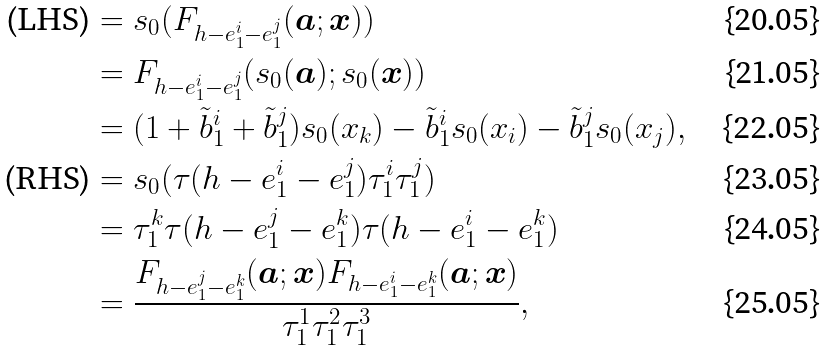<formula> <loc_0><loc_0><loc_500><loc_500>\text {(LHS)} & = s _ { 0 } ( F _ { h - e _ { 1 } ^ { i } - e _ { 1 } ^ { j } } ( { \boldsymbol a } ; { \boldsymbol x } ) ) \\ & = F _ { h - e _ { 1 } ^ { i } - e _ { 1 } ^ { j } } ( s _ { 0 } ( { \boldsymbol a } ) ; s _ { 0 } ( { \boldsymbol x } ) ) \\ & = ( 1 + \tilde { b } _ { 1 } ^ { i } + \tilde { b } _ { 1 } ^ { j } ) s _ { 0 } ( x _ { k } ) - \tilde { b } _ { 1 } ^ { i } s _ { 0 } ( x _ { i } ) - \tilde { b } _ { 1 } ^ { j } s _ { 0 } ( x _ { j } ) , \\ \text {(RHS)} & = s _ { 0 } ( \tau ( h - e _ { 1 } ^ { i } - e _ { 1 } ^ { j } ) \tau _ { 1 } ^ { i } \tau _ { 1 } ^ { j } ) \\ & = \tau _ { 1 } ^ { k } \tau ( h - e _ { 1 } ^ { j } - e _ { 1 } ^ { k } ) \tau ( h - e _ { 1 } ^ { i } - e _ { 1 } ^ { k } ) \\ & = \frac { F _ { h - e _ { 1 } ^ { j } - e _ { 1 } ^ { k } } ( { \boldsymbol a } ; { \boldsymbol x } ) F _ { h - e _ { 1 } ^ { i } - e _ { 1 } ^ { k } } ( { \boldsymbol a } ; { \boldsymbol x } ) } { \tau _ { 1 } ^ { 1 } \tau _ { 1 } ^ { 2 } \tau _ { 1 } ^ { 3 } } ,</formula> 